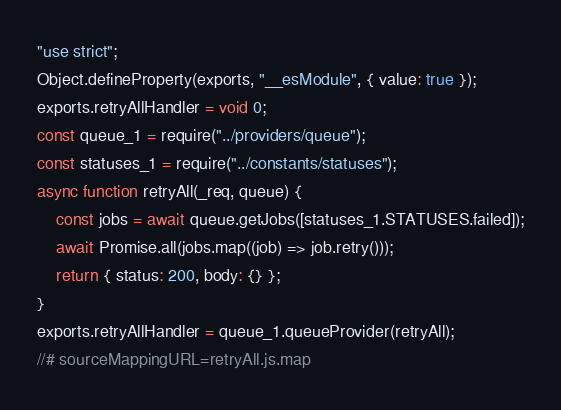<code> <loc_0><loc_0><loc_500><loc_500><_JavaScript_>"use strict";
Object.defineProperty(exports, "__esModule", { value: true });
exports.retryAllHandler = void 0;
const queue_1 = require("../providers/queue");
const statuses_1 = require("../constants/statuses");
async function retryAll(_req, queue) {
    const jobs = await queue.getJobs([statuses_1.STATUSES.failed]);
    await Promise.all(jobs.map((job) => job.retry()));
    return { status: 200, body: {} };
}
exports.retryAllHandler = queue_1.queueProvider(retryAll);
//# sourceMappingURL=retryAll.js.map</code> 